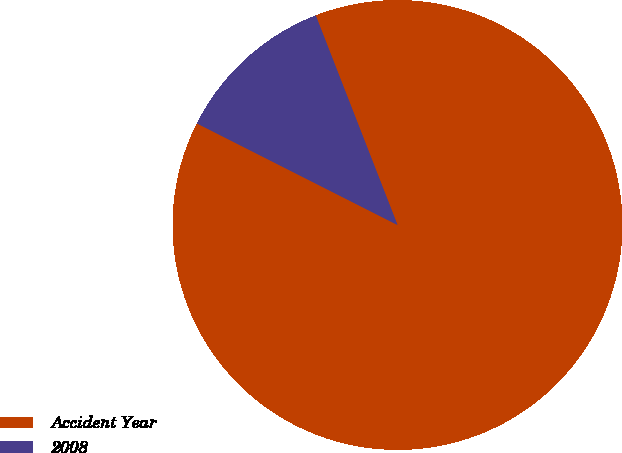Convert chart to OTSL. <chart><loc_0><loc_0><loc_500><loc_500><pie_chart><fcel>Accident Year<fcel>2008<nl><fcel>88.38%<fcel>11.62%<nl></chart> 